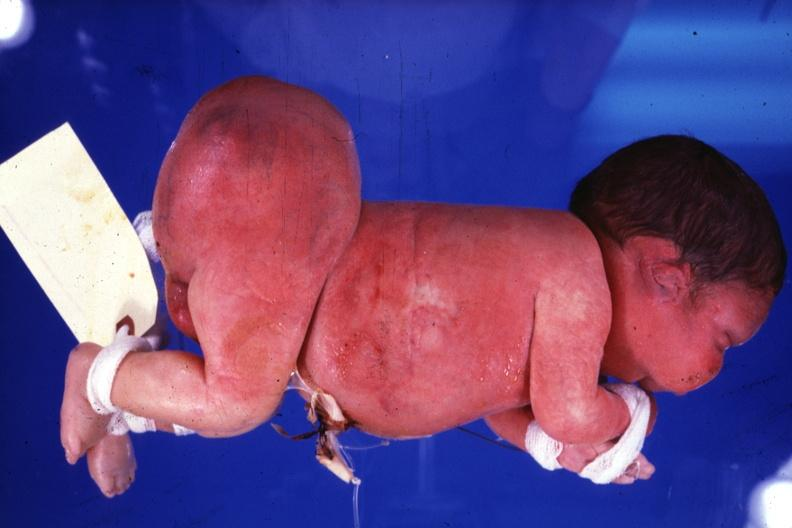does this image show lateral view of body with grossly enlarged buttocks area?
Answer the question using a single word or phrase. Yes 